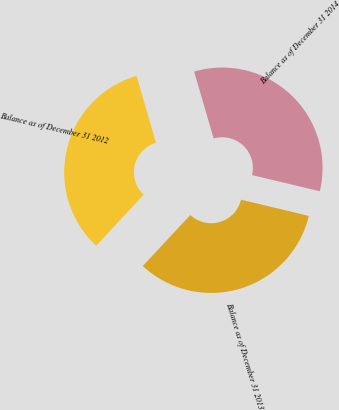<chart> <loc_0><loc_0><loc_500><loc_500><pie_chart><fcel>Balance as of December 31 2012<fcel>Balance as of December 31 2013<fcel>Balance as of December 31 2014<nl><fcel>33.56%<fcel>33.2%<fcel>33.24%<nl></chart> 